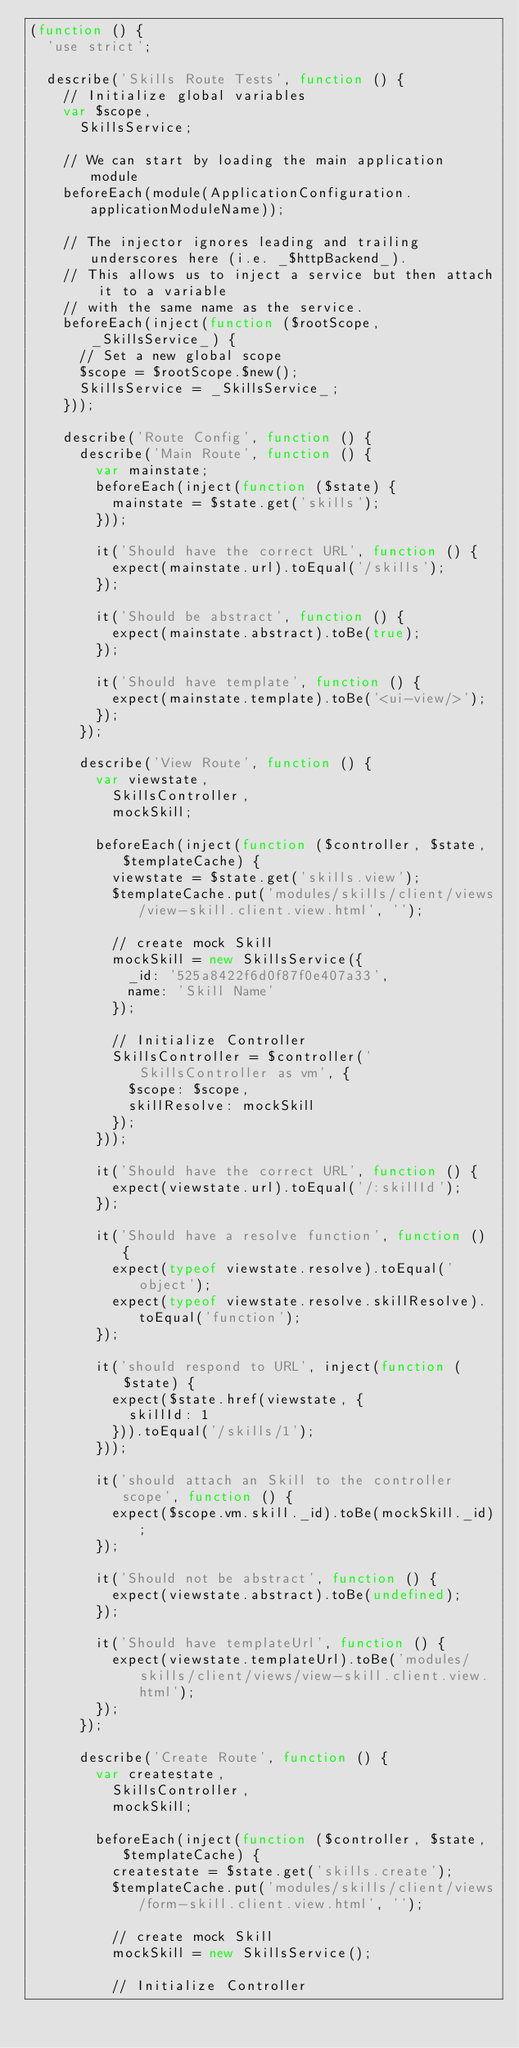Convert code to text. <code><loc_0><loc_0><loc_500><loc_500><_JavaScript_>(function () {
  'use strict';

  describe('Skills Route Tests', function () {
    // Initialize global variables
    var $scope,
      SkillsService;

    // We can start by loading the main application module
    beforeEach(module(ApplicationConfiguration.applicationModuleName));

    // The injector ignores leading and trailing underscores here (i.e. _$httpBackend_).
    // This allows us to inject a service but then attach it to a variable
    // with the same name as the service.
    beforeEach(inject(function ($rootScope, _SkillsService_) {
      // Set a new global scope
      $scope = $rootScope.$new();
      SkillsService = _SkillsService_;
    }));

    describe('Route Config', function () {
      describe('Main Route', function () {
        var mainstate;
        beforeEach(inject(function ($state) {
          mainstate = $state.get('skills');
        }));

        it('Should have the correct URL', function () {
          expect(mainstate.url).toEqual('/skills');
        });

        it('Should be abstract', function () {
          expect(mainstate.abstract).toBe(true);
        });

        it('Should have template', function () {
          expect(mainstate.template).toBe('<ui-view/>');
        });
      });

      describe('View Route', function () {
        var viewstate,
          SkillsController,
          mockSkill;

        beforeEach(inject(function ($controller, $state, $templateCache) {
          viewstate = $state.get('skills.view');
          $templateCache.put('modules/skills/client/views/view-skill.client.view.html', '');

          // create mock Skill
          mockSkill = new SkillsService({
            _id: '525a8422f6d0f87f0e407a33',
            name: 'Skill Name'
          });

          // Initialize Controller
          SkillsController = $controller('SkillsController as vm', {
            $scope: $scope,
            skillResolve: mockSkill
          });
        }));

        it('Should have the correct URL', function () {
          expect(viewstate.url).toEqual('/:skillId');
        });

        it('Should have a resolve function', function () {
          expect(typeof viewstate.resolve).toEqual('object');
          expect(typeof viewstate.resolve.skillResolve).toEqual('function');
        });

        it('should respond to URL', inject(function ($state) {
          expect($state.href(viewstate, {
            skillId: 1
          })).toEqual('/skills/1');
        }));

        it('should attach an Skill to the controller scope', function () {
          expect($scope.vm.skill._id).toBe(mockSkill._id);
        });

        it('Should not be abstract', function () {
          expect(viewstate.abstract).toBe(undefined);
        });

        it('Should have templateUrl', function () {
          expect(viewstate.templateUrl).toBe('modules/skills/client/views/view-skill.client.view.html');
        });
      });

      describe('Create Route', function () {
        var createstate,
          SkillsController,
          mockSkill;

        beforeEach(inject(function ($controller, $state, $templateCache) {
          createstate = $state.get('skills.create');
          $templateCache.put('modules/skills/client/views/form-skill.client.view.html', '');

          // create mock Skill
          mockSkill = new SkillsService();

          // Initialize Controller</code> 